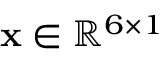<formula> <loc_0><loc_0><loc_500><loc_500>x \in \mathbb { R } ^ { 6 \times 1 }</formula> 